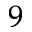<formula> <loc_0><loc_0><loc_500><loc_500>^ { 9 }</formula> 